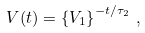Convert formula to latex. <formula><loc_0><loc_0><loc_500><loc_500>V ( t ) = \left \{ V _ { 1 } \right \} ^ { - t / \tau _ { 2 } } \, ,</formula> 